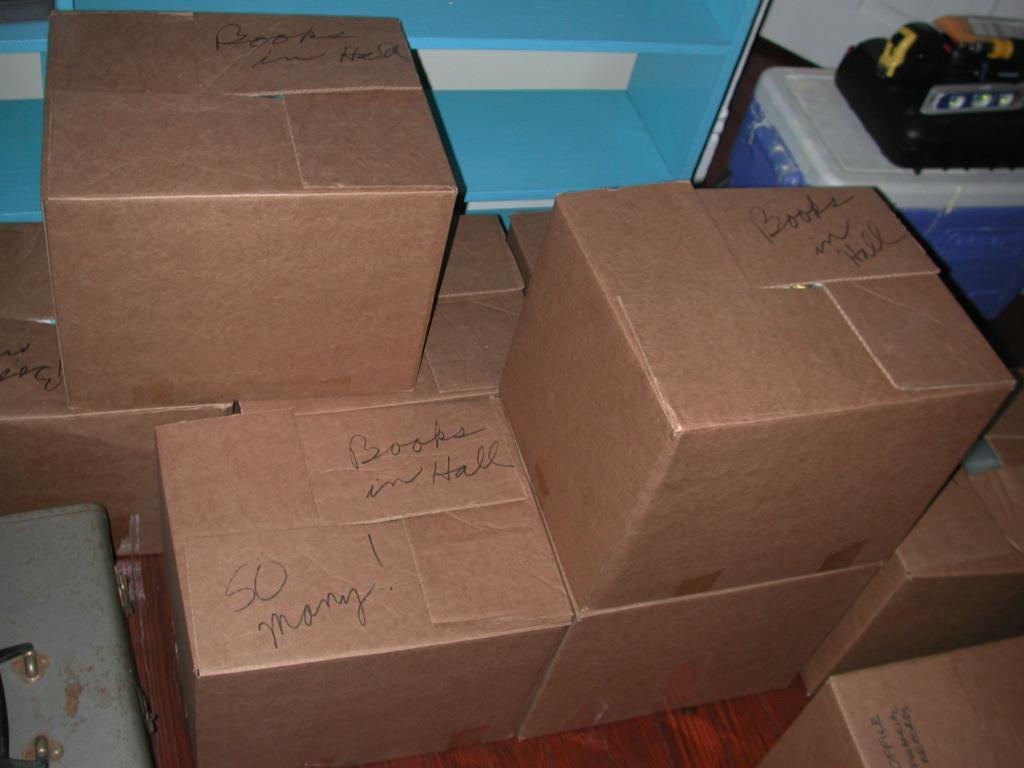Please provide a concise description of this image. In this image we can see some cardboard boxes placed on the floor. In the background we can see a blue color shelf and we can also see a black color text on the top of the cardboard boxes. 